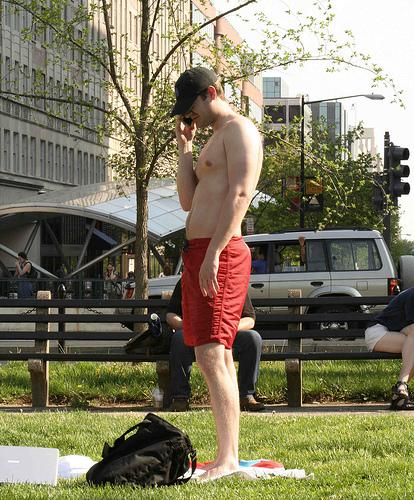Question: what color are his shorts?
Choices:
A. Red.
B. Blue.
C. Green.
D. Yellow.
Answer with the letter. Answer: A Question: who is on the bench?
Choices:
A. Children.
B. A man.
C. Two women.
D. A couple people.
Answer with the letter. Answer: D Question: what is on the ground?
Choices:
A. A backpack.
B. A suitcase.
C. A briefcase.
D. A sack.
Answer with the letter. Answer: A Question: what is on the man's head?
Choices:
A. A helmet.
B. Sunglasses.
C. Shirt.
D. A hat.
Answer with the letter. Answer: D Question: what is he standing on?
Choices:
A. Pavement.
B. Stones.
C. Grass.
D. Wood.
Answer with the letter. Answer: C 